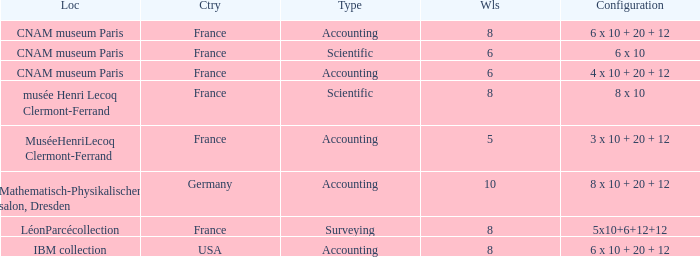What average wheels has accounting as the type, with IBM Collection as the location? 8.0. 